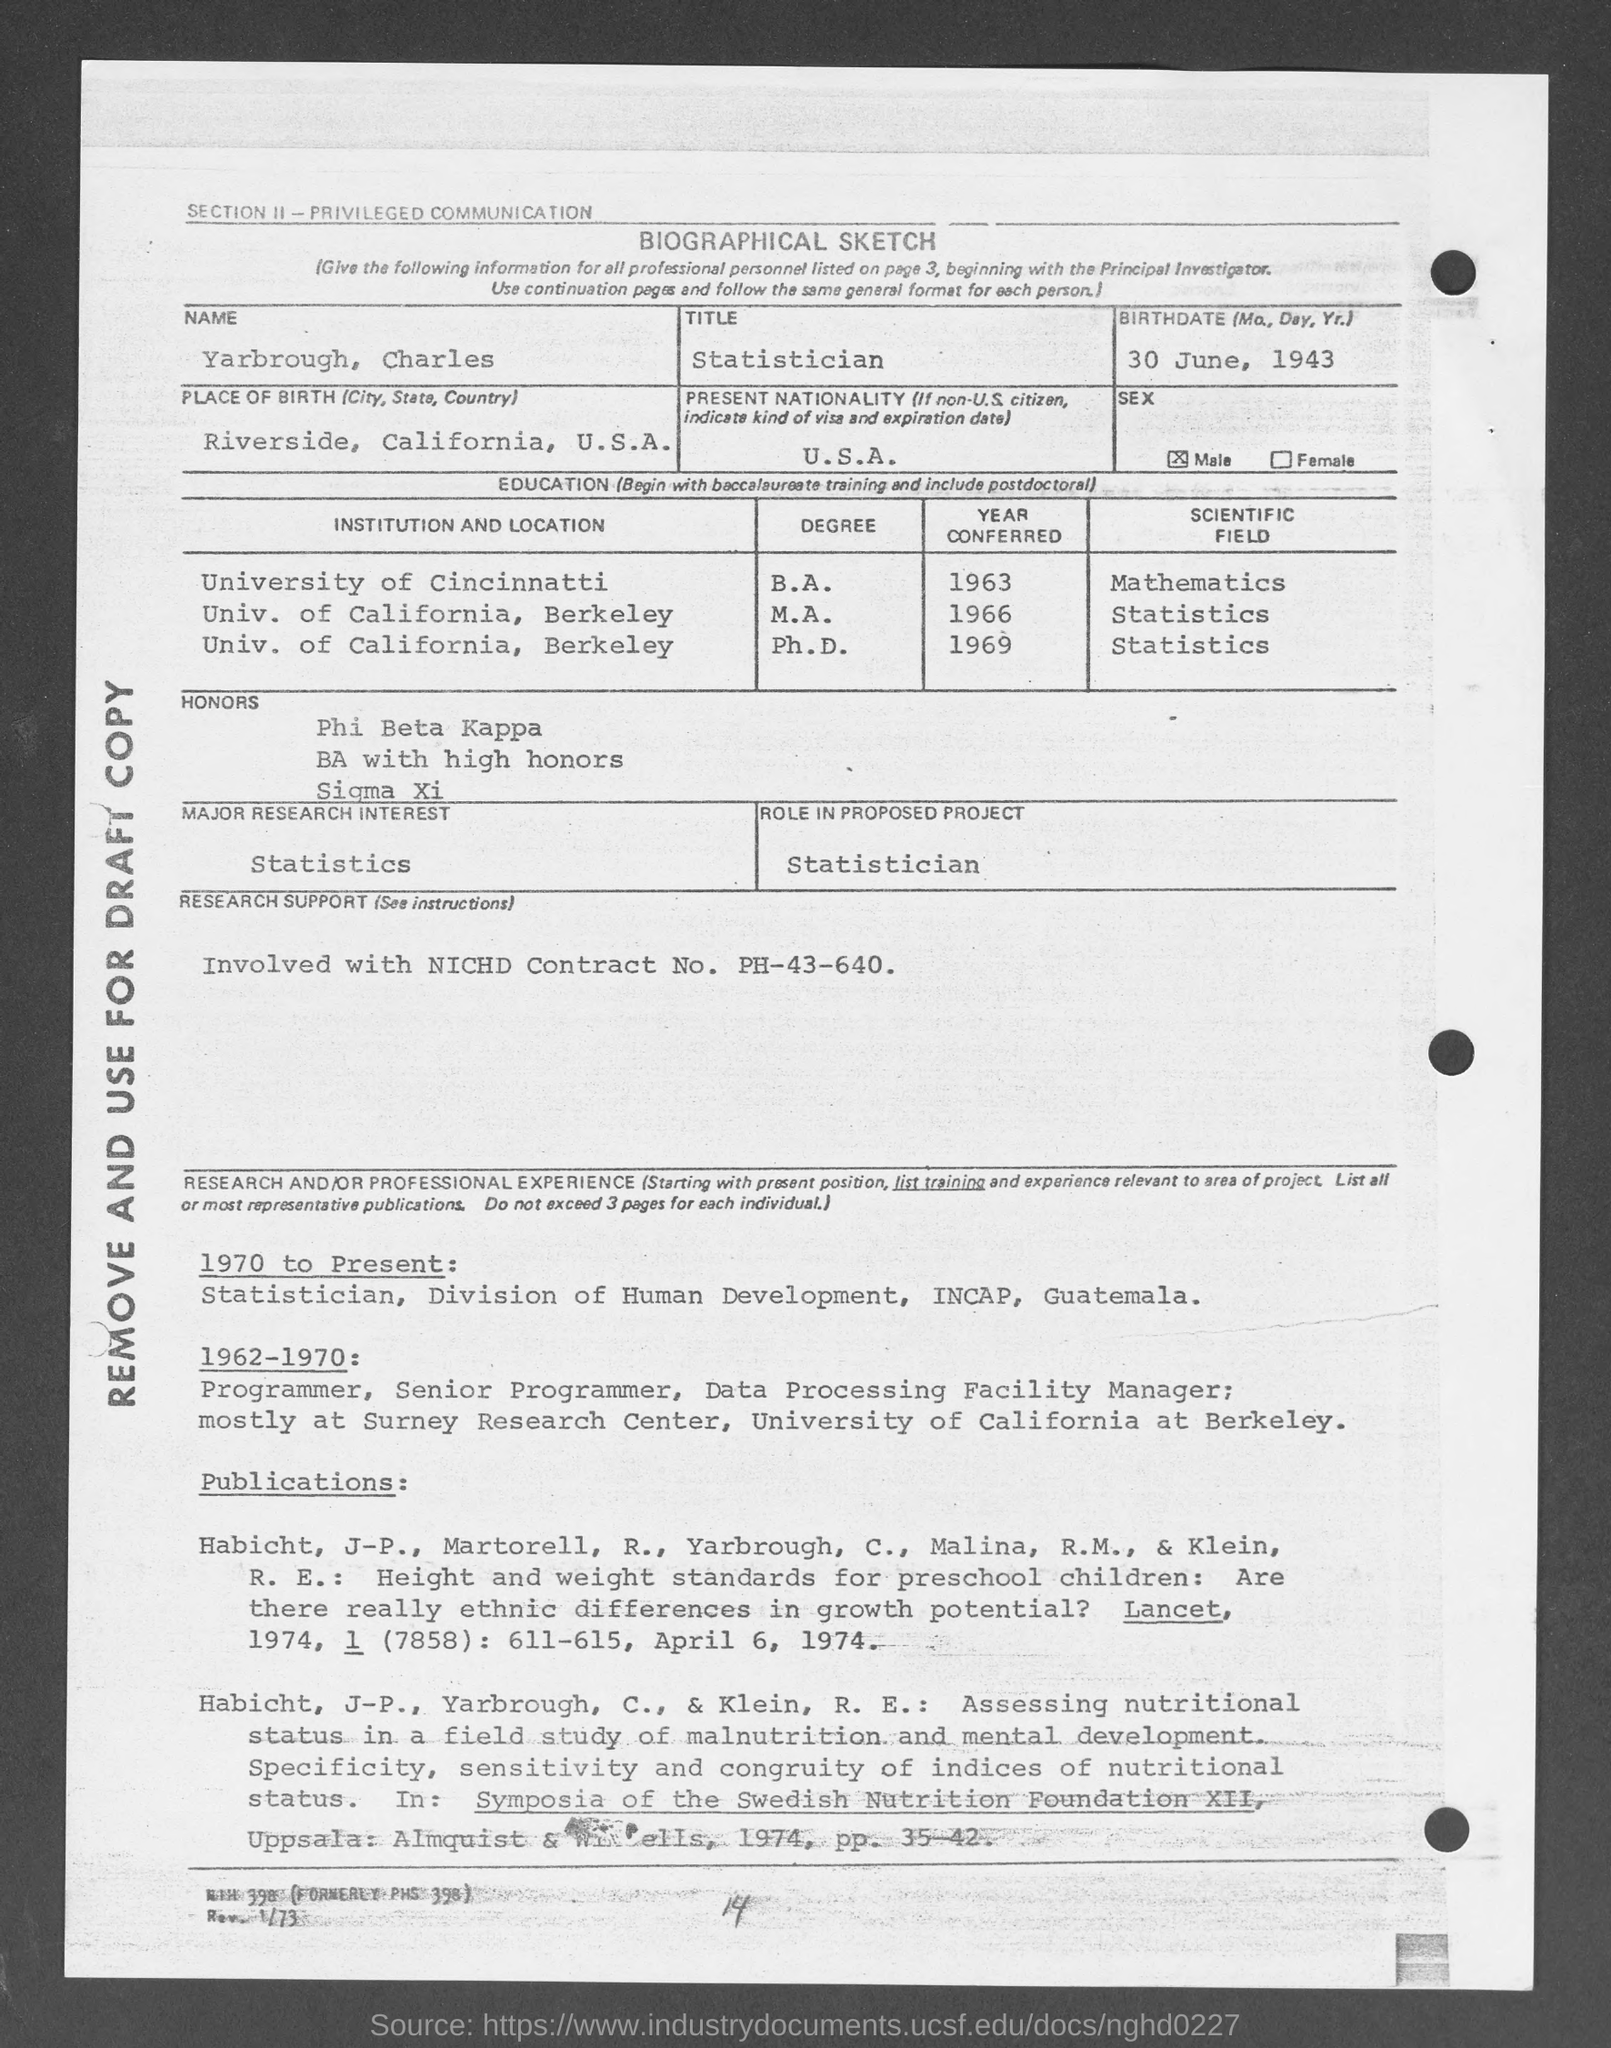List a handful of essential elements in this visual. My title is Statistician. It is known that he was enrolled at the University of Cincinnati in 1963. The present nationality of the speaker is the United States of America. On June 30, 1943, the person in question was born. The major research interest is statistics. 